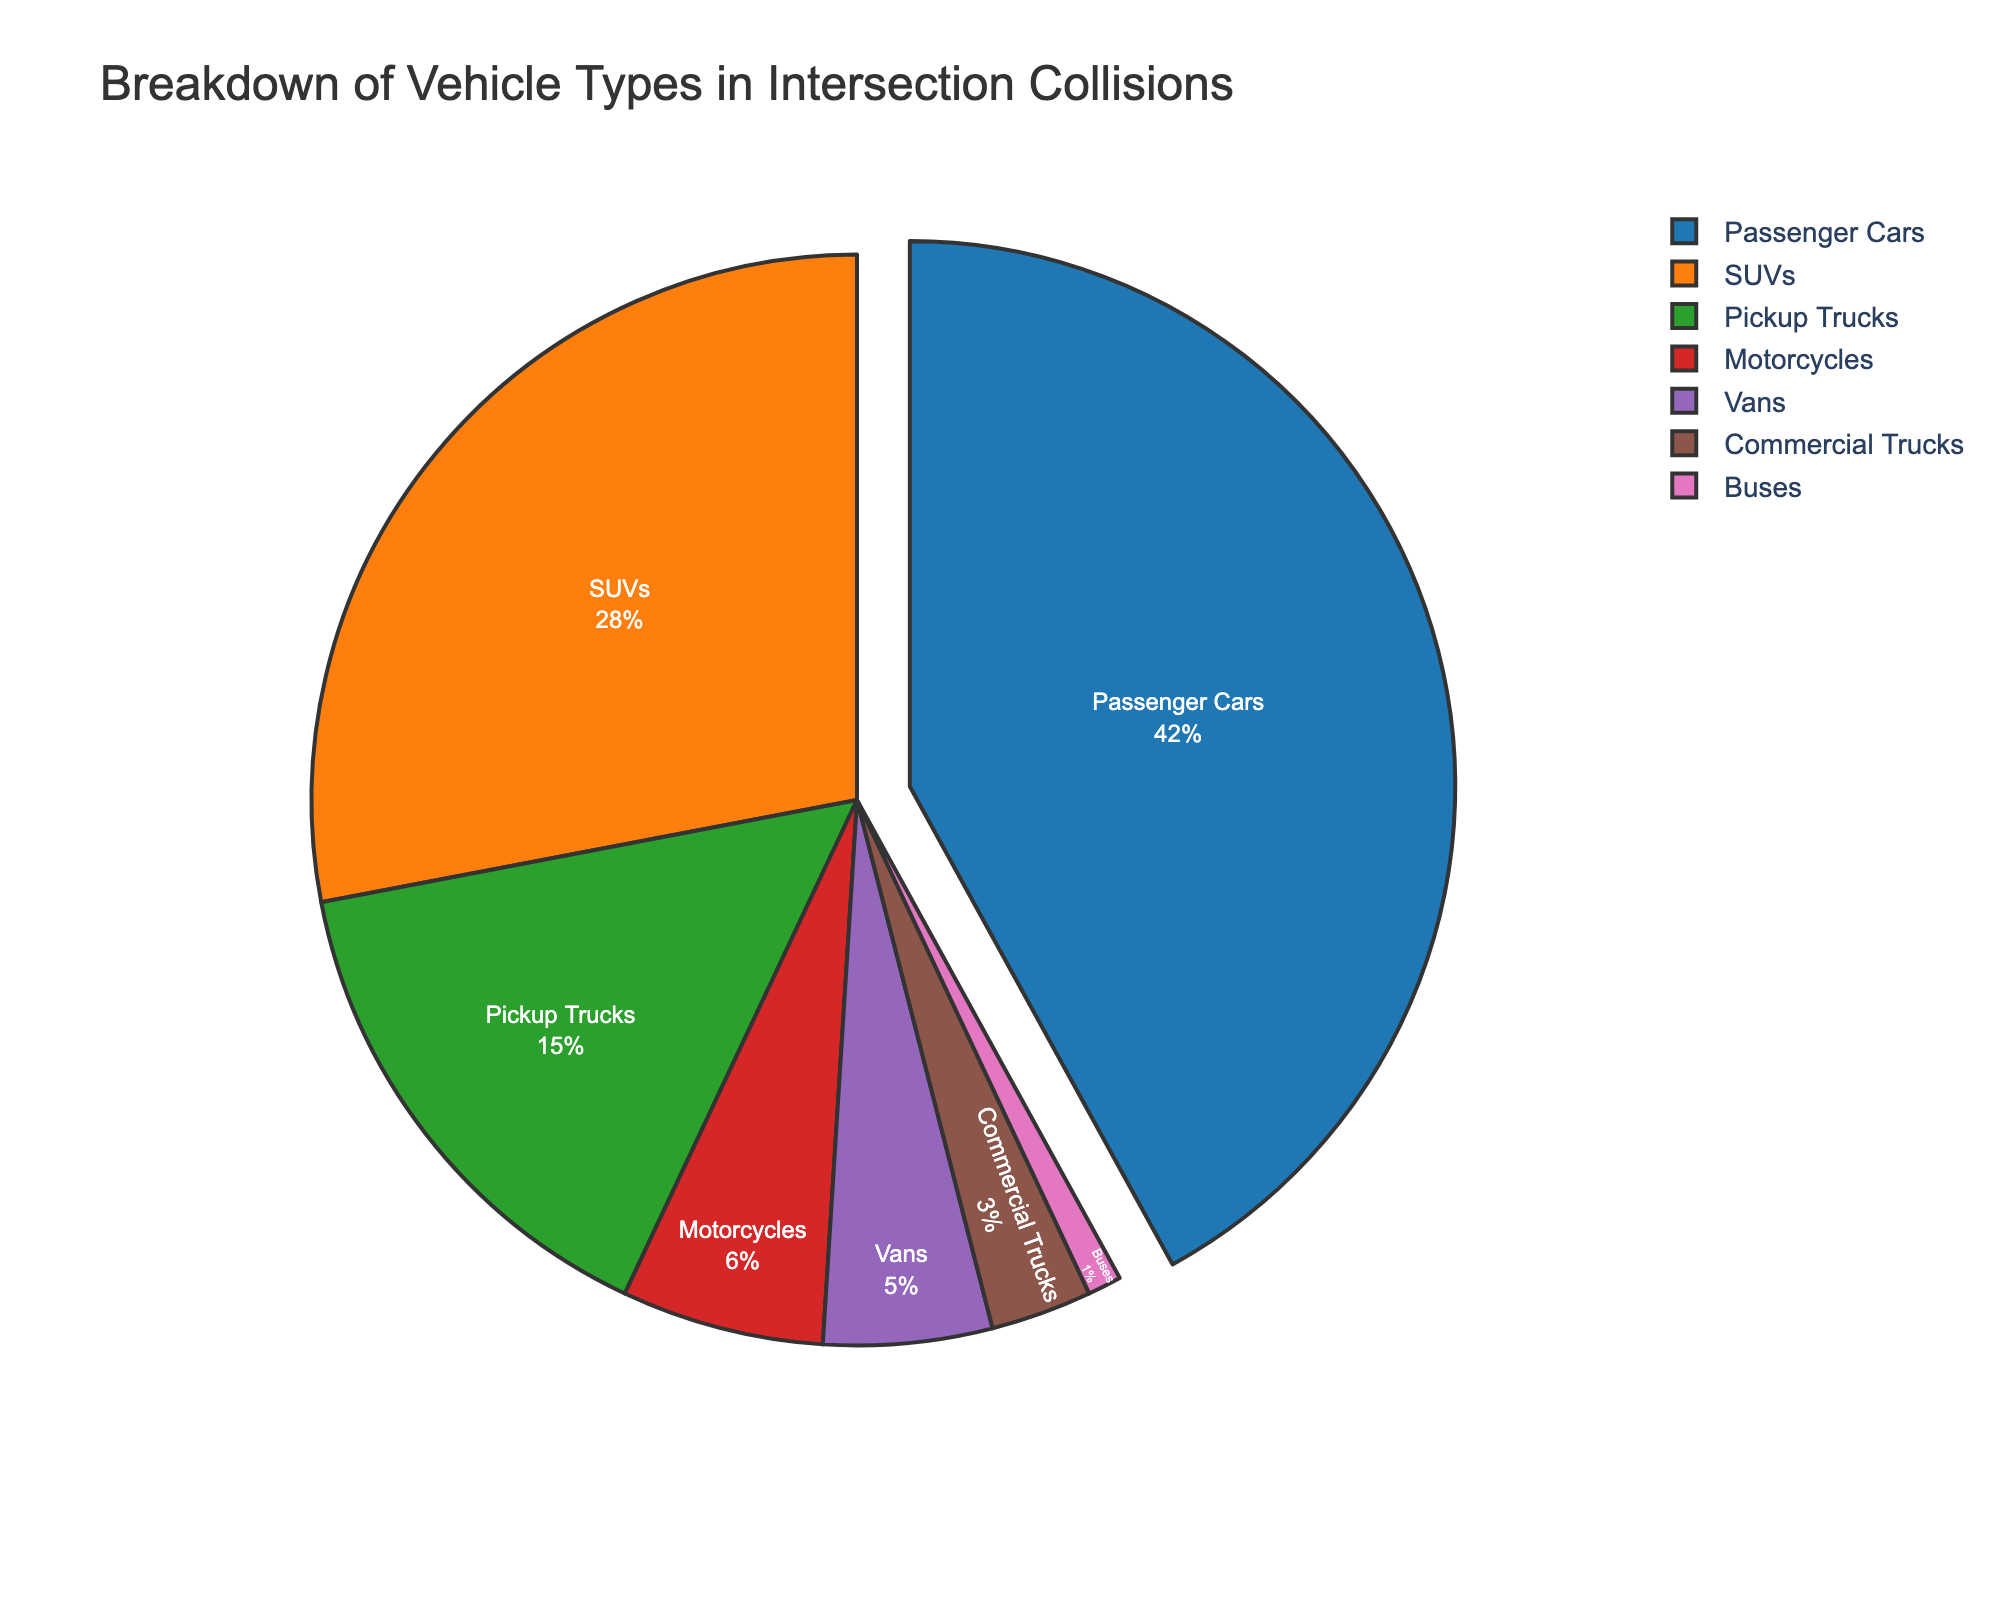What vehicle type has the highest percentage in intersection collisions? The pie chart indicates that passenger cars occupy the largest section, showing 42% of the total collisions.
Answer: Passenger cars Which vehicle types together make up more than half of the intersection collisions? Combining the percentages of passenger cars (42%) and SUVs (28%) exceeds 50%, specifically totaling 70%.
Answer: Passenger cars and SUVs How does the percentage of pickup trucks compare to that of motorcycles? The percentage for pickup trucks is 15%, while motorcycles are 6%. Pickup trucks are therefore more commonly involved in collisions than motorcycles.
Answer: Pickup trucks have a higher percentage What is the combined percentage of vans and commercial trucks involved in intersection collisions? The chart shows vans at 5% and commercial trucks at 3%. Adding these percentages, we get 5% + 3% = 8%.
Answer: 8% What vehicle type represents the smallest percentage of intersection collisions? Examining the pie chart reveals that buses account for the smallest segment at only 1%.
Answer: Buses How much more likely are SUVs to be involved in an intersection collision compared to motorcycles? SUVs have a 28% involvement rate, while motorcycles have 6%. The difference is 28% - 6% = 22%, indicating SUVs are 22% more likely to be involved.
Answer: 22% What percentage of intersection collisions involve either commercial trucks or buses? Adding the percentages for commercial trucks (3%) and buses (1%), the total is 4%.
Answer: 4% If we exclude passenger cars and SUVs, what percentage of intersection collisions involve other vehicle types? The total percentage of passenger cars and SUVs is 42% + 28% = 70%. Excluding these, the remaining vehicle types make up 100% - 70% = 30%.
Answer: 30% What is the difference in collision percentages between vans and motorcycles? Vans are involved in 5% of collisions, and motorcycles are in 6%. The difference is 6% - 5% = 1%.
Answer: 1% 